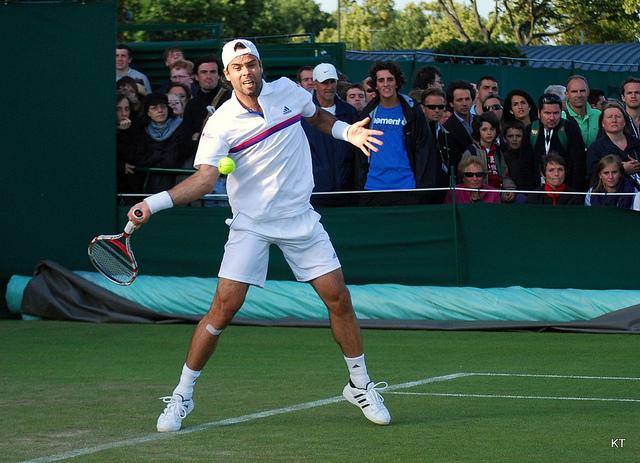How many tennis balls do you see?
Keep it brief. 1. Is this person standing on his toes?
Keep it brief. Yes. Is his left hand clenched?
Give a very brief answer. No. Will this woman likely be successful in returning the ball?
Write a very short answer. Yes. What game is being played?
Write a very short answer. Tennis. Does the shirt have sleeves?
Be succinct. Yes. What does the man have on his knees?
Write a very short answer. Bandage. How many people are shown?
Keep it brief. 31. What color is the man's pants in the background?
Quick response, please. Blue. What color are the man's shorts?
Answer briefly. White. 